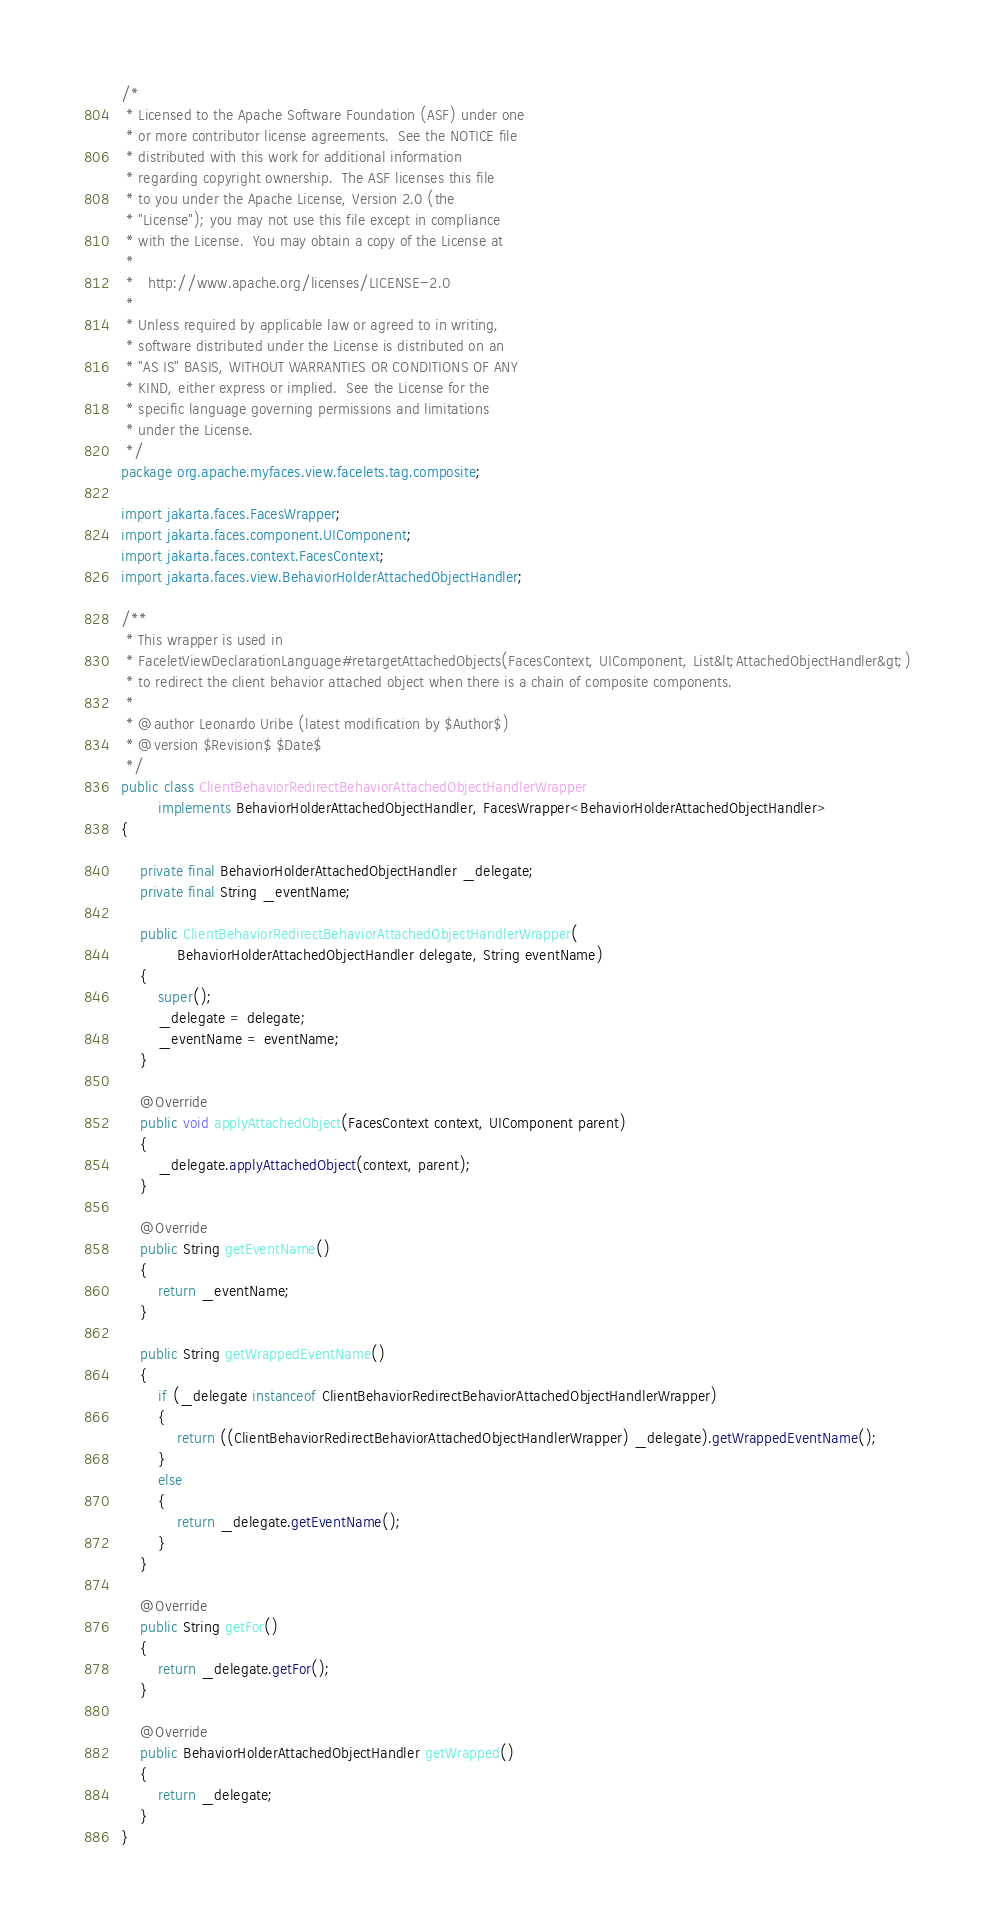Convert code to text. <code><loc_0><loc_0><loc_500><loc_500><_Java_>/*
 * Licensed to the Apache Software Foundation (ASF) under one
 * or more contributor license agreements.  See the NOTICE file
 * distributed with this work for additional information
 * regarding copyright ownership.  The ASF licenses this file
 * to you under the Apache License, Version 2.0 (the
 * "License"); you may not use this file except in compliance
 * with the License.  You may obtain a copy of the License at
 *
 *   http://www.apache.org/licenses/LICENSE-2.0
 *
 * Unless required by applicable law or agreed to in writing,
 * software distributed under the License is distributed on an
 * "AS IS" BASIS, WITHOUT WARRANTIES OR CONDITIONS OF ANY
 * KIND, either express or implied.  See the License for the
 * specific language governing permissions and limitations
 * under the License.
 */
package org.apache.myfaces.view.facelets.tag.composite;

import jakarta.faces.FacesWrapper;
import jakarta.faces.component.UIComponent;
import jakarta.faces.context.FacesContext;
import jakarta.faces.view.BehaviorHolderAttachedObjectHandler;

/**
 * This wrapper is used in
 * FaceletViewDeclarationLanguage#retargetAttachedObjects(FacesContext, UIComponent, List&lt;AttachedObjectHandler&gt;)
 * to redirect the client behavior attached object when there is a chain of composite components.  
 * 
 * @author Leonardo Uribe (latest modification by $Author$)
 * @version $Revision$ $Date$
 */
public class ClientBehaviorRedirectBehaviorAttachedObjectHandlerWrapper
        implements BehaviorHolderAttachedObjectHandler, FacesWrapper<BehaviorHolderAttachedObjectHandler>
{
    
    private final BehaviorHolderAttachedObjectHandler _delegate;
    private final String _eventName;

    public ClientBehaviorRedirectBehaviorAttachedObjectHandlerWrapper(
            BehaviorHolderAttachedObjectHandler delegate, String eventName)
    {
        super();
        _delegate = delegate;
        _eventName = eventName;
    }

    @Override
    public void applyAttachedObject(FacesContext context, UIComponent parent)
    {
        _delegate.applyAttachedObject(context, parent);
    }

    @Override
    public String getEventName()
    {
        return _eventName;
    }
    
    public String getWrappedEventName()
    {
        if (_delegate instanceof ClientBehaviorRedirectBehaviorAttachedObjectHandlerWrapper)
        {
            return ((ClientBehaviorRedirectBehaviorAttachedObjectHandlerWrapper) _delegate).getWrappedEventName();
        }
        else
        {
            return _delegate.getEventName();
        }
    }

    @Override
    public String getFor()
    {
        return _delegate.getFor();
    }

    @Override
    public BehaviorHolderAttachedObjectHandler getWrapped()
    {
        return _delegate;
    }
}
</code> 